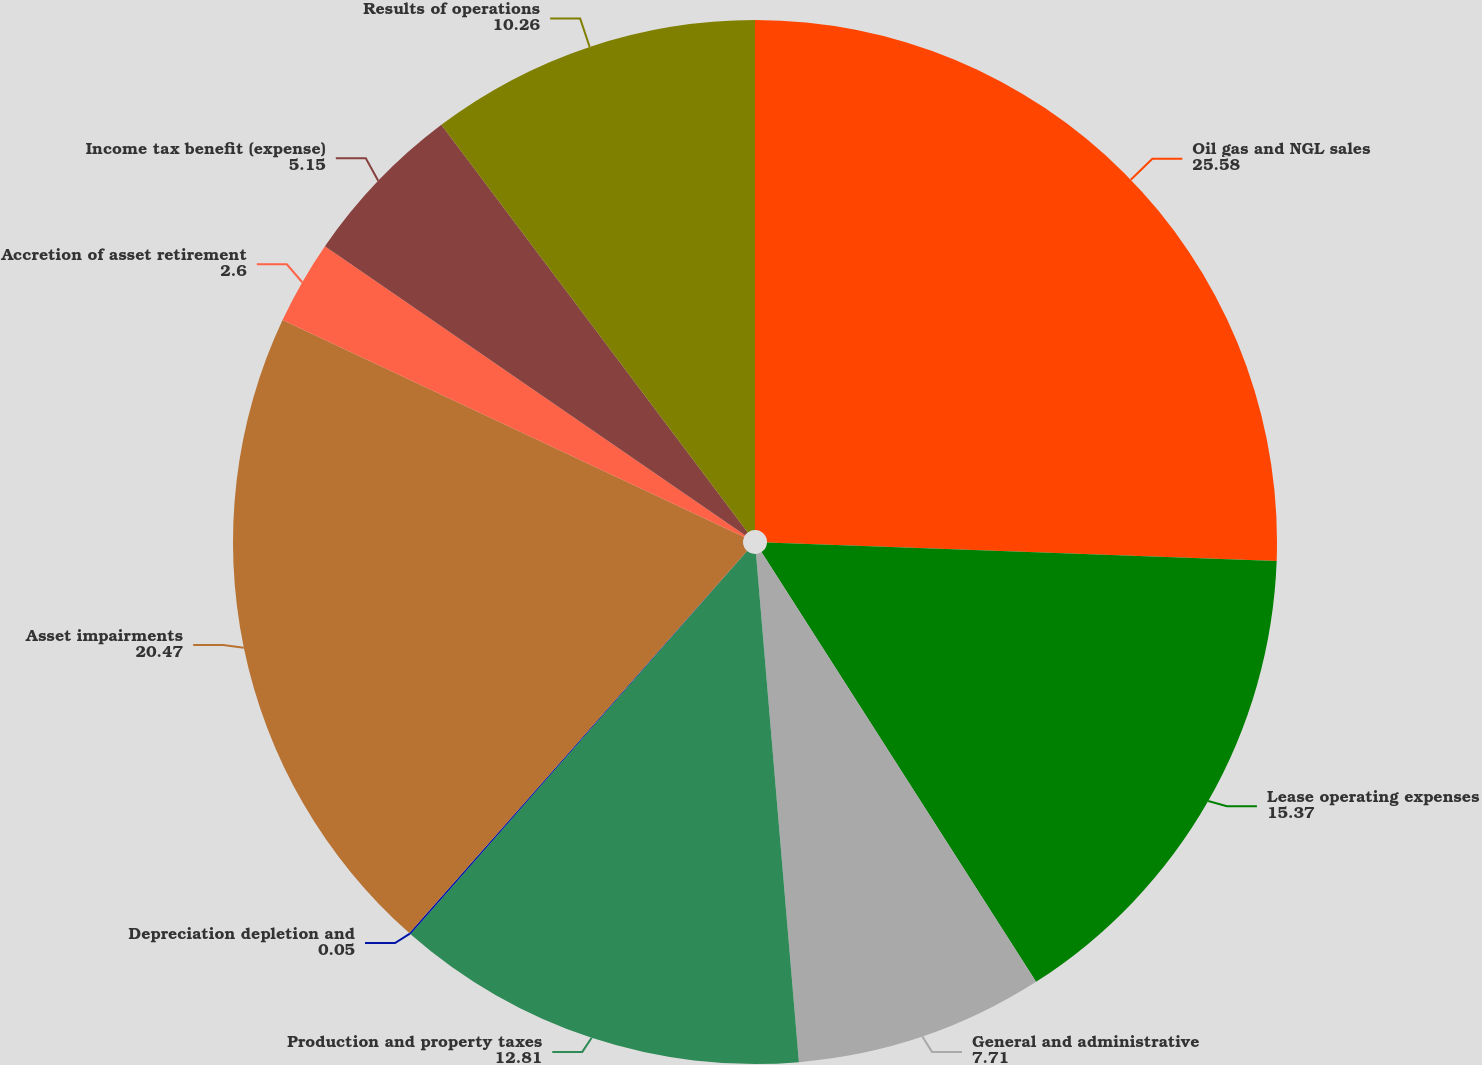<chart> <loc_0><loc_0><loc_500><loc_500><pie_chart><fcel>Oil gas and NGL sales<fcel>Lease operating expenses<fcel>General and administrative<fcel>Production and property taxes<fcel>Depreciation depletion and<fcel>Asset impairments<fcel>Accretion of asset retirement<fcel>Income tax benefit (expense)<fcel>Results of operations<nl><fcel>25.58%<fcel>15.37%<fcel>7.71%<fcel>12.81%<fcel>0.05%<fcel>20.47%<fcel>2.6%<fcel>5.15%<fcel>10.26%<nl></chart> 